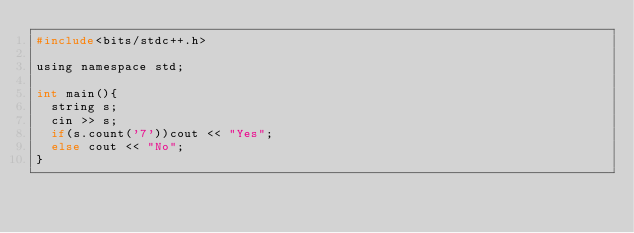<code> <loc_0><loc_0><loc_500><loc_500><_C_>#include<bits/stdc++.h>

using namespace std;

int main(){
	string s;
  cin >> s;
  if(s.count('7'))cout << "Yes";
  else cout << "No";
}</code> 